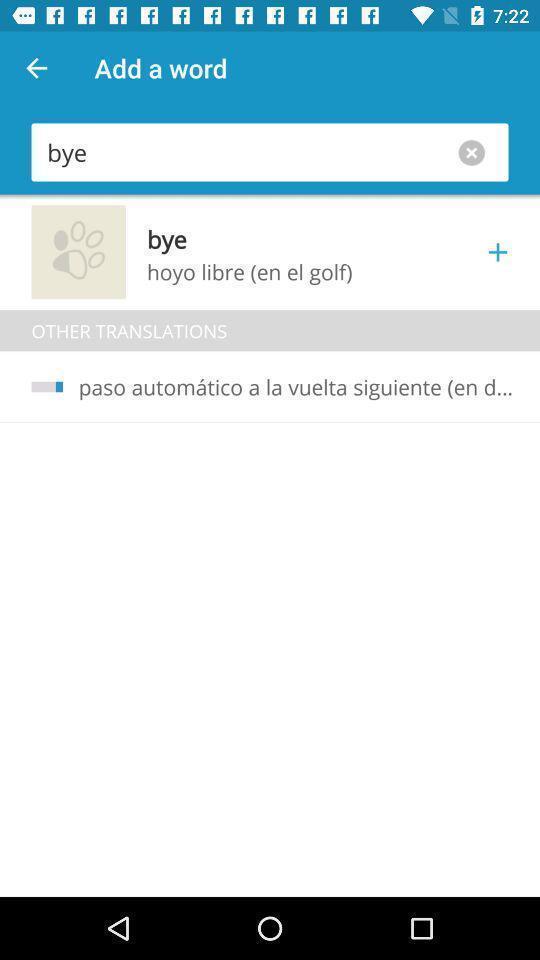Describe the visual elements of this screenshot. Page with search bar in an translator application. 